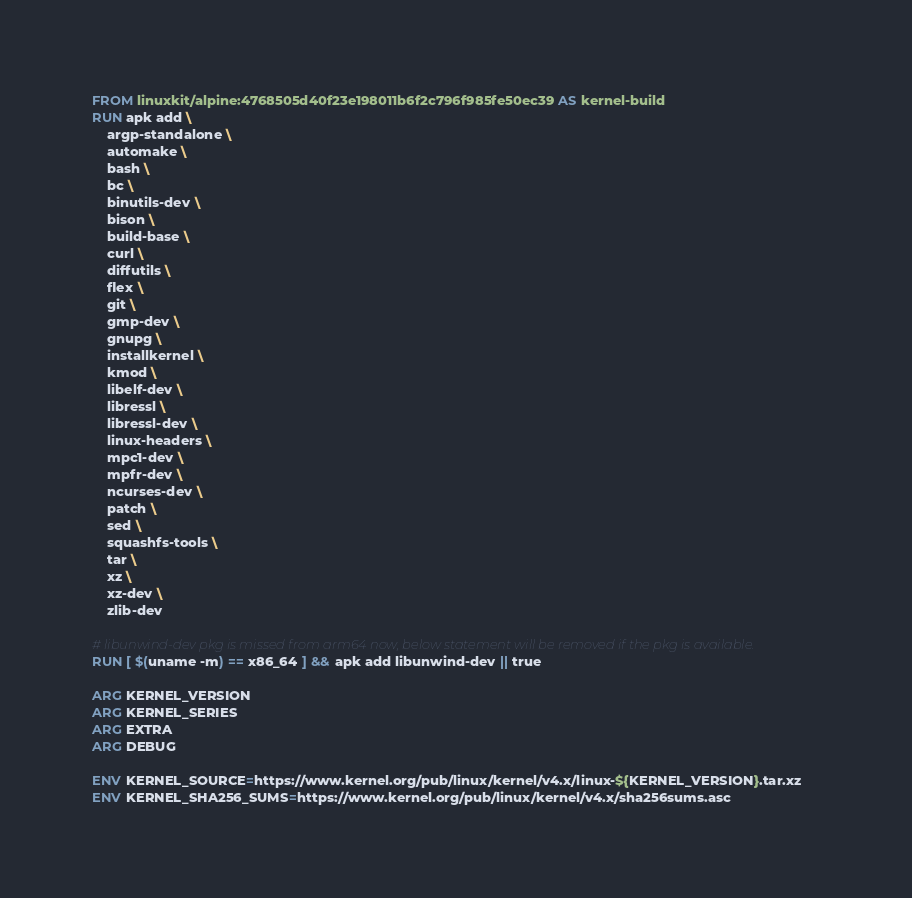Convert code to text. <code><loc_0><loc_0><loc_500><loc_500><_Dockerfile_>FROM linuxkit/alpine:4768505d40f23e198011b6f2c796f985fe50ec39 AS kernel-build
RUN apk add \
    argp-standalone \
    automake \
    bash \
    bc \
    binutils-dev \
    bison \
    build-base \
    curl \
    diffutils \
    flex \
    git \
    gmp-dev \
    gnupg \
    installkernel \
    kmod \
    libelf-dev \
    libressl \
    libressl-dev \
    linux-headers \
    mpc1-dev \
    mpfr-dev \
    ncurses-dev \
    patch \
    sed \
    squashfs-tools \
    tar \
    xz \
    xz-dev \
    zlib-dev

# libunwind-dev pkg is missed from arm64 now, below statement will be removed if the pkg is available.
RUN [ $(uname -m) == x86_64 ] && apk add libunwind-dev || true

ARG KERNEL_VERSION
ARG KERNEL_SERIES
ARG EXTRA
ARG DEBUG

ENV KERNEL_SOURCE=https://www.kernel.org/pub/linux/kernel/v4.x/linux-${KERNEL_VERSION}.tar.xz
ENV KERNEL_SHA256_SUMS=https://www.kernel.org/pub/linux/kernel/v4.x/sha256sums.asc</code> 